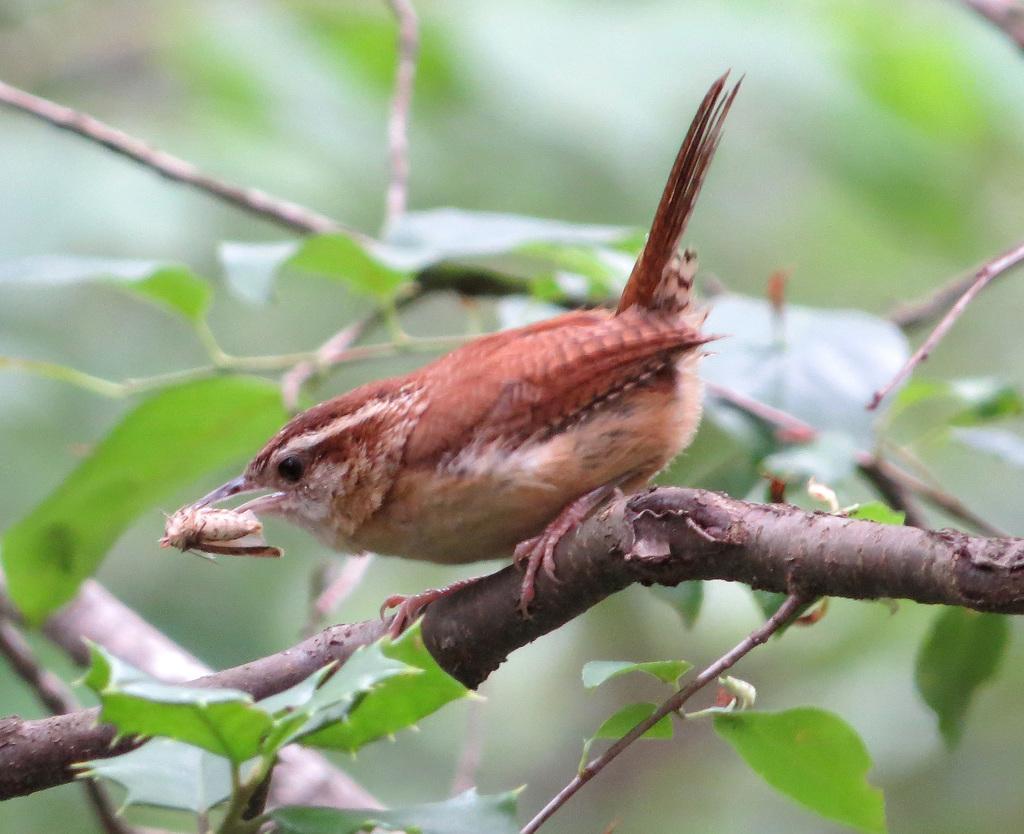In one or two sentences, can you explain what this image depicts? In the center of the image there is a bird on the tree branch. There is a some object in the bird's mouth. 